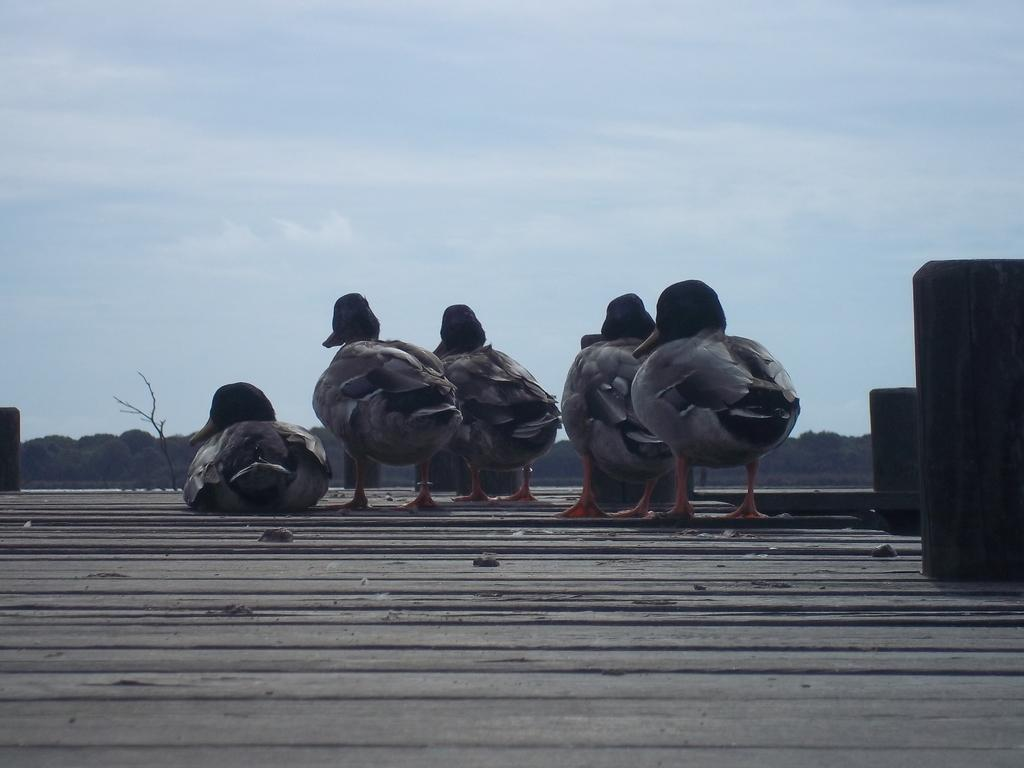What animals are present on the wooden surface in the image? There are ducks on a wooden surface in the image. What type of vegetation can be seen in the background of the image? There are trees in the background of the image. What part of the natural environment is visible in the background of the image? The sky is visible in the background of the image. What type of poison is being used by the ducks in the image? There is no poison present in the image; the ducks are simply standing on a wooden surface. 